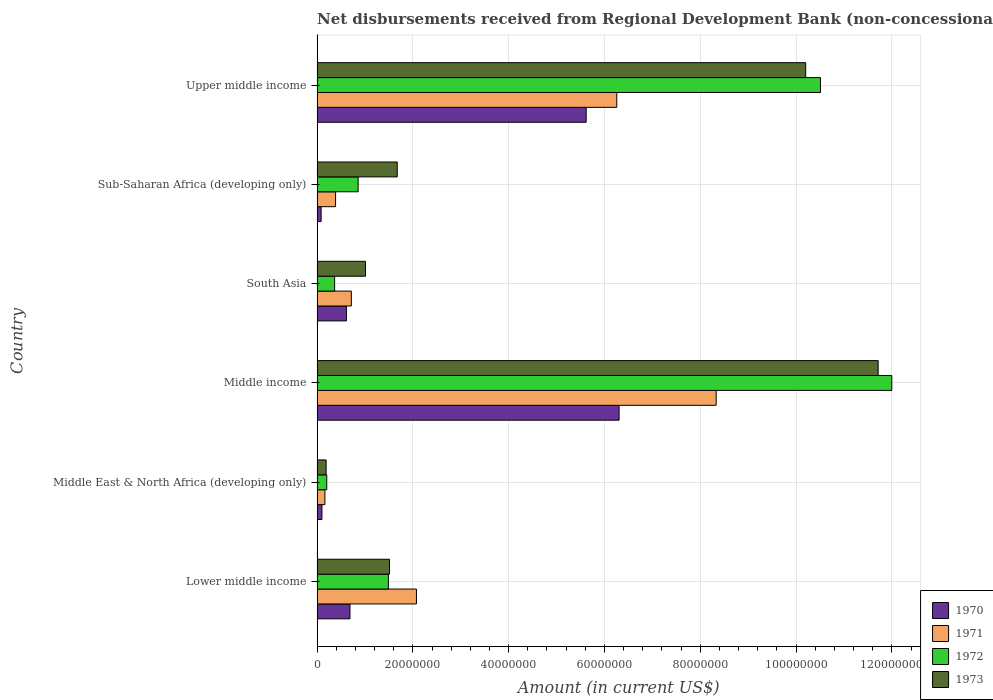How many groups of bars are there?
Your answer should be very brief. 6. Are the number of bars per tick equal to the number of legend labels?
Provide a succinct answer. Yes. What is the label of the 2nd group of bars from the top?
Make the answer very short. Sub-Saharan Africa (developing only). In how many cases, is the number of bars for a given country not equal to the number of legend labels?
Offer a very short reply. 0. What is the amount of disbursements received from Regional Development Bank in 1971 in Upper middle income?
Your answer should be compact. 6.26e+07. Across all countries, what is the maximum amount of disbursements received from Regional Development Bank in 1970?
Your answer should be compact. 6.31e+07. Across all countries, what is the minimum amount of disbursements received from Regional Development Bank in 1973?
Offer a very short reply. 1.90e+06. In which country was the amount of disbursements received from Regional Development Bank in 1971 minimum?
Your response must be concise. Middle East & North Africa (developing only). What is the total amount of disbursements received from Regional Development Bank in 1973 in the graph?
Provide a succinct answer. 2.63e+08. What is the difference between the amount of disbursements received from Regional Development Bank in 1971 in Lower middle income and that in Sub-Saharan Africa (developing only)?
Your response must be concise. 1.69e+07. What is the difference between the amount of disbursements received from Regional Development Bank in 1970 in Sub-Saharan Africa (developing only) and the amount of disbursements received from Regional Development Bank in 1971 in Middle East & North Africa (developing only)?
Ensure brevity in your answer.  -7.85e+05. What is the average amount of disbursements received from Regional Development Bank in 1970 per country?
Provide a short and direct response. 2.24e+07. What is the difference between the amount of disbursements received from Regional Development Bank in 1970 and amount of disbursements received from Regional Development Bank in 1973 in Lower middle income?
Your answer should be compact. -8.26e+06. In how many countries, is the amount of disbursements received from Regional Development Bank in 1971 greater than 116000000 US$?
Offer a terse response. 0. What is the ratio of the amount of disbursements received from Regional Development Bank in 1971 in South Asia to that in Upper middle income?
Keep it short and to the point. 0.11. What is the difference between the highest and the second highest amount of disbursements received from Regional Development Bank in 1970?
Keep it short and to the point. 6.87e+06. What is the difference between the highest and the lowest amount of disbursements received from Regional Development Bank in 1971?
Make the answer very short. 8.17e+07. Is the sum of the amount of disbursements received from Regional Development Bank in 1973 in Middle East & North Africa (developing only) and Middle income greater than the maximum amount of disbursements received from Regional Development Bank in 1971 across all countries?
Your answer should be compact. Yes. What does the 4th bar from the top in Middle income represents?
Provide a succinct answer. 1970. What does the 1st bar from the bottom in Sub-Saharan Africa (developing only) represents?
Make the answer very short. 1970. Are all the bars in the graph horizontal?
Keep it short and to the point. Yes. How many countries are there in the graph?
Offer a terse response. 6. What is the difference between two consecutive major ticks on the X-axis?
Provide a short and direct response. 2.00e+07. Are the values on the major ticks of X-axis written in scientific E-notation?
Your response must be concise. No. Does the graph contain any zero values?
Your answer should be very brief. No. Where does the legend appear in the graph?
Make the answer very short. Bottom right. How are the legend labels stacked?
Make the answer very short. Vertical. What is the title of the graph?
Your response must be concise. Net disbursements received from Regional Development Bank (non-concessional). What is the label or title of the X-axis?
Give a very brief answer. Amount (in current US$). What is the Amount (in current US$) in 1970 in Lower middle income?
Keep it short and to the point. 6.87e+06. What is the Amount (in current US$) in 1971 in Lower middle income?
Offer a very short reply. 2.08e+07. What is the Amount (in current US$) of 1972 in Lower middle income?
Ensure brevity in your answer.  1.49e+07. What is the Amount (in current US$) in 1973 in Lower middle income?
Offer a very short reply. 1.51e+07. What is the Amount (in current US$) in 1970 in Middle East & North Africa (developing only)?
Keep it short and to the point. 1.02e+06. What is the Amount (in current US$) in 1971 in Middle East & North Africa (developing only)?
Your answer should be very brief. 1.64e+06. What is the Amount (in current US$) of 1972 in Middle East & North Africa (developing only)?
Keep it short and to the point. 2.02e+06. What is the Amount (in current US$) in 1973 in Middle East & North Africa (developing only)?
Your answer should be compact. 1.90e+06. What is the Amount (in current US$) of 1970 in Middle income?
Ensure brevity in your answer.  6.31e+07. What is the Amount (in current US$) of 1971 in Middle income?
Keep it short and to the point. 8.33e+07. What is the Amount (in current US$) of 1972 in Middle income?
Offer a terse response. 1.20e+08. What is the Amount (in current US$) of 1973 in Middle income?
Give a very brief answer. 1.17e+08. What is the Amount (in current US$) of 1970 in South Asia?
Your answer should be very brief. 6.13e+06. What is the Amount (in current US$) of 1971 in South Asia?
Provide a short and direct response. 7.16e+06. What is the Amount (in current US$) in 1972 in South Asia?
Your answer should be compact. 3.67e+06. What is the Amount (in current US$) of 1973 in South Asia?
Ensure brevity in your answer.  1.01e+07. What is the Amount (in current US$) in 1970 in Sub-Saharan Africa (developing only)?
Keep it short and to the point. 8.50e+05. What is the Amount (in current US$) of 1971 in Sub-Saharan Africa (developing only)?
Your answer should be very brief. 3.87e+06. What is the Amount (in current US$) of 1972 in Sub-Saharan Africa (developing only)?
Your answer should be very brief. 8.58e+06. What is the Amount (in current US$) in 1973 in Sub-Saharan Africa (developing only)?
Give a very brief answer. 1.67e+07. What is the Amount (in current US$) in 1970 in Upper middle income?
Provide a succinct answer. 5.62e+07. What is the Amount (in current US$) of 1971 in Upper middle income?
Give a very brief answer. 6.26e+07. What is the Amount (in current US$) of 1972 in Upper middle income?
Offer a terse response. 1.05e+08. What is the Amount (in current US$) in 1973 in Upper middle income?
Your answer should be very brief. 1.02e+08. Across all countries, what is the maximum Amount (in current US$) of 1970?
Offer a terse response. 6.31e+07. Across all countries, what is the maximum Amount (in current US$) in 1971?
Provide a short and direct response. 8.33e+07. Across all countries, what is the maximum Amount (in current US$) in 1972?
Provide a short and direct response. 1.20e+08. Across all countries, what is the maximum Amount (in current US$) of 1973?
Your response must be concise. 1.17e+08. Across all countries, what is the minimum Amount (in current US$) in 1970?
Your response must be concise. 8.50e+05. Across all countries, what is the minimum Amount (in current US$) of 1971?
Provide a succinct answer. 1.64e+06. Across all countries, what is the minimum Amount (in current US$) of 1972?
Give a very brief answer. 2.02e+06. Across all countries, what is the minimum Amount (in current US$) in 1973?
Provide a succinct answer. 1.90e+06. What is the total Amount (in current US$) of 1970 in the graph?
Provide a succinct answer. 1.34e+08. What is the total Amount (in current US$) in 1971 in the graph?
Keep it short and to the point. 1.79e+08. What is the total Amount (in current US$) in 1972 in the graph?
Provide a short and direct response. 2.54e+08. What is the total Amount (in current US$) in 1973 in the graph?
Provide a succinct answer. 2.63e+08. What is the difference between the Amount (in current US$) in 1970 in Lower middle income and that in Middle East & North Africa (developing only)?
Give a very brief answer. 5.85e+06. What is the difference between the Amount (in current US$) in 1971 in Lower middle income and that in Middle East & North Africa (developing only)?
Your response must be concise. 1.91e+07. What is the difference between the Amount (in current US$) of 1972 in Lower middle income and that in Middle East & North Africa (developing only)?
Offer a very short reply. 1.29e+07. What is the difference between the Amount (in current US$) of 1973 in Lower middle income and that in Middle East & North Africa (developing only)?
Make the answer very short. 1.32e+07. What is the difference between the Amount (in current US$) in 1970 in Lower middle income and that in Middle income?
Your answer should be very brief. -5.62e+07. What is the difference between the Amount (in current US$) of 1971 in Lower middle income and that in Middle income?
Offer a very short reply. -6.26e+07. What is the difference between the Amount (in current US$) in 1972 in Lower middle income and that in Middle income?
Offer a very short reply. -1.05e+08. What is the difference between the Amount (in current US$) in 1973 in Lower middle income and that in Middle income?
Your answer should be very brief. -1.02e+08. What is the difference between the Amount (in current US$) in 1970 in Lower middle income and that in South Asia?
Your response must be concise. 7.37e+05. What is the difference between the Amount (in current US$) of 1971 in Lower middle income and that in South Asia?
Your response must be concise. 1.36e+07. What is the difference between the Amount (in current US$) of 1972 in Lower middle income and that in South Asia?
Offer a terse response. 1.12e+07. What is the difference between the Amount (in current US$) in 1973 in Lower middle income and that in South Asia?
Provide a succinct answer. 5.02e+06. What is the difference between the Amount (in current US$) of 1970 in Lower middle income and that in Sub-Saharan Africa (developing only)?
Your answer should be compact. 6.02e+06. What is the difference between the Amount (in current US$) in 1971 in Lower middle income and that in Sub-Saharan Africa (developing only)?
Your answer should be very brief. 1.69e+07. What is the difference between the Amount (in current US$) of 1972 in Lower middle income and that in Sub-Saharan Africa (developing only)?
Offer a very short reply. 6.32e+06. What is the difference between the Amount (in current US$) in 1973 in Lower middle income and that in Sub-Saharan Africa (developing only)?
Provide a succinct answer. -1.61e+06. What is the difference between the Amount (in current US$) of 1970 in Lower middle income and that in Upper middle income?
Ensure brevity in your answer.  -4.93e+07. What is the difference between the Amount (in current US$) in 1971 in Lower middle income and that in Upper middle income?
Your answer should be compact. -4.18e+07. What is the difference between the Amount (in current US$) of 1972 in Lower middle income and that in Upper middle income?
Offer a terse response. -9.02e+07. What is the difference between the Amount (in current US$) in 1973 in Lower middle income and that in Upper middle income?
Offer a terse response. -8.69e+07. What is the difference between the Amount (in current US$) in 1970 in Middle East & North Africa (developing only) and that in Middle income?
Keep it short and to the point. -6.20e+07. What is the difference between the Amount (in current US$) of 1971 in Middle East & North Africa (developing only) and that in Middle income?
Ensure brevity in your answer.  -8.17e+07. What is the difference between the Amount (in current US$) of 1972 in Middle East & North Africa (developing only) and that in Middle income?
Provide a short and direct response. -1.18e+08. What is the difference between the Amount (in current US$) of 1973 in Middle East & North Africa (developing only) and that in Middle income?
Provide a succinct answer. -1.15e+08. What is the difference between the Amount (in current US$) of 1970 in Middle East & North Africa (developing only) and that in South Asia?
Offer a very short reply. -5.11e+06. What is the difference between the Amount (in current US$) of 1971 in Middle East & North Africa (developing only) and that in South Asia?
Give a very brief answer. -5.52e+06. What is the difference between the Amount (in current US$) in 1972 in Middle East & North Africa (developing only) and that in South Asia?
Your response must be concise. -1.64e+06. What is the difference between the Amount (in current US$) of 1973 in Middle East & North Africa (developing only) and that in South Asia?
Give a very brief answer. -8.22e+06. What is the difference between the Amount (in current US$) in 1970 in Middle East & North Africa (developing only) and that in Sub-Saharan Africa (developing only)?
Provide a short and direct response. 1.71e+05. What is the difference between the Amount (in current US$) of 1971 in Middle East & North Africa (developing only) and that in Sub-Saharan Africa (developing only)?
Give a very brief answer. -2.23e+06. What is the difference between the Amount (in current US$) of 1972 in Middle East & North Africa (developing only) and that in Sub-Saharan Africa (developing only)?
Provide a succinct answer. -6.56e+06. What is the difference between the Amount (in current US$) in 1973 in Middle East & North Africa (developing only) and that in Sub-Saharan Africa (developing only)?
Offer a terse response. -1.48e+07. What is the difference between the Amount (in current US$) in 1970 in Middle East & North Africa (developing only) and that in Upper middle income?
Provide a succinct answer. -5.52e+07. What is the difference between the Amount (in current US$) of 1971 in Middle East & North Africa (developing only) and that in Upper middle income?
Provide a short and direct response. -6.09e+07. What is the difference between the Amount (in current US$) of 1972 in Middle East & North Africa (developing only) and that in Upper middle income?
Your response must be concise. -1.03e+08. What is the difference between the Amount (in current US$) in 1973 in Middle East & North Africa (developing only) and that in Upper middle income?
Ensure brevity in your answer.  -1.00e+08. What is the difference between the Amount (in current US$) in 1970 in Middle income and that in South Asia?
Your answer should be compact. 5.69e+07. What is the difference between the Amount (in current US$) of 1971 in Middle income and that in South Asia?
Provide a short and direct response. 7.62e+07. What is the difference between the Amount (in current US$) in 1972 in Middle income and that in South Asia?
Your answer should be compact. 1.16e+08. What is the difference between the Amount (in current US$) of 1973 in Middle income and that in South Asia?
Your answer should be compact. 1.07e+08. What is the difference between the Amount (in current US$) of 1970 in Middle income and that in Sub-Saharan Africa (developing only)?
Your answer should be very brief. 6.22e+07. What is the difference between the Amount (in current US$) of 1971 in Middle income and that in Sub-Saharan Africa (developing only)?
Offer a very short reply. 7.95e+07. What is the difference between the Amount (in current US$) of 1972 in Middle income and that in Sub-Saharan Africa (developing only)?
Offer a very short reply. 1.11e+08. What is the difference between the Amount (in current US$) in 1973 in Middle income and that in Sub-Saharan Africa (developing only)?
Make the answer very short. 1.00e+08. What is the difference between the Amount (in current US$) in 1970 in Middle income and that in Upper middle income?
Give a very brief answer. 6.87e+06. What is the difference between the Amount (in current US$) in 1971 in Middle income and that in Upper middle income?
Provide a short and direct response. 2.08e+07. What is the difference between the Amount (in current US$) in 1972 in Middle income and that in Upper middle income?
Offer a terse response. 1.49e+07. What is the difference between the Amount (in current US$) in 1973 in Middle income and that in Upper middle income?
Provide a short and direct response. 1.51e+07. What is the difference between the Amount (in current US$) in 1970 in South Asia and that in Sub-Saharan Africa (developing only)?
Provide a short and direct response. 5.28e+06. What is the difference between the Amount (in current US$) of 1971 in South Asia and that in Sub-Saharan Africa (developing only)?
Give a very brief answer. 3.29e+06. What is the difference between the Amount (in current US$) in 1972 in South Asia and that in Sub-Saharan Africa (developing only)?
Your answer should be compact. -4.91e+06. What is the difference between the Amount (in current US$) in 1973 in South Asia and that in Sub-Saharan Africa (developing only)?
Your answer should be very brief. -6.63e+06. What is the difference between the Amount (in current US$) of 1970 in South Asia and that in Upper middle income?
Provide a short and direct response. -5.01e+07. What is the difference between the Amount (in current US$) in 1971 in South Asia and that in Upper middle income?
Ensure brevity in your answer.  -5.54e+07. What is the difference between the Amount (in current US$) in 1972 in South Asia and that in Upper middle income?
Your answer should be very brief. -1.01e+08. What is the difference between the Amount (in current US$) in 1973 in South Asia and that in Upper middle income?
Keep it short and to the point. -9.19e+07. What is the difference between the Amount (in current US$) of 1970 in Sub-Saharan Africa (developing only) and that in Upper middle income?
Make the answer very short. -5.53e+07. What is the difference between the Amount (in current US$) in 1971 in Sub-Saharan Africa (developing only) and that in Upper middle income?
Make the answer very short. -5.87e+07. What is the difference between the Amount (in current US$) of 1972 in Sub-Saharan Africa (developing only) and that in Upper middle income?
Your answer should be compact. -9.65e+07. What is the difference between the Amount (in current US$) in 1973 in Sub-Saharan Africa (developing only) and that in Upper middle income?
Your answer should be compact. -8.53e+07. What is the difference between the Amount (in current US$) in 1970 in Lower middle income and the Amount (in current US$) in 1971 in Middle East & North Africa (developing only)?
Give a very brief answer. 5.24e+06. What is the difference between the Amount (in current US$) in 1970 in Lower middle income and the Amount (in current US$) in 1972 in Middle East & North Africa (developing only)?
Provide a succinct answer. 4.85e+06. What is the difference between the Amount (in current US$) in 1970 in Lower middle income and the Amount (in current US$) in 1973 in Middle East & North Africa (developing only)?
Ensure brevity in your answer.  4.98e+06. What is the difference between the Amount (in current US$) of 1971 in Lower middle income and the Amount (in current US$) of 1972 in Middle East & North Africa (developing only)?
Your answer should be very brief. 1.87e+07. What is the difference between the Amount (in current US$) in 1971 in Lower middle income and the Amount (in current US$) in 1973 in Middle East & North Africa (developing only)?
Your response must be concise. 1.89e+07. What is the difference between the Amount (in current US$) of 1972 in Lower middle income and the Amount (in current US$) of 1973 in Middle East & North Africa (developing only)?
Make the answer very short. 1.30e+07. What is the difference between the Amount (in current US$) of 1970 in Lower middle income and the Amount (in current US$) of 1971 in Middle income?
Your answer should be compact. -7.65e+07. What is the difference between the Amount (in current US$) in 1970 in Lower middle income and the Amount (in current US$) in 1972 in Middle income?
Ensure brevity in your answer.  -1.13e+08. What is the difference between the Amount (in current US$) in 1970 in Lower middle income and the Amount (in current US$) in 1973 in Middle income?
Your answer should be compact. -1.10e+08. What is the difference between the Amount (in current US$) in 1971 in Lower middle income and the Amount (in current US$) in 1972 in Middle income?
Provide a succinct answer. -9.92e+07. What is the difference between the Amount (in current US$) of 1971 in Lower middle income and the Amount (in current US$) of 1973 in Middle income?
Make the answer very short. -9.64e+07. What is the difference between the Amount (in current US$) in 1972 in Lower middle income and the Amount (in current US$) in 1973 in Middle income?
Your answer should be compact. -1.02e+08. What is the difference between the Amount (in current US$) of 1970 in Lower middle income and the Amount (in current US$) of 1971 in South Asia?
Ensure brevity in your answer.  -2.87e+05. What is the difference between the Amount (in current US$) in 1970 in Lower middle income and the Amount (in current US$) in 1972 in South Asia?
Offer a terse response. 3.20e+06. What is the difference between the Amount (in current US$) of 1970 in Lower middle income and the Amount (in current US$) of 1973 in South Asia?
Ensure brevity in your answer.  -3.24e+06. What is the difference between the Amount (in current US$) of 1971 in Lower middle income and the Amount (in current US$) of 1972 in South Asia?
Your answer should be compact. 1.71e+07. What is the difference between the Amount (in current US$) of 1971 in Lower middle income and the Amount (in current US$) of 1973 in South Asia?
Offer a terse response. 1.06e+07. What is the difference between the Amount (in current US$) in 1972 in Lower middle income and the Amount (in current US$) in 1973 in South Asia?
Provide a succinct answer. 4.78e+06. What is the difference between the Amount (in current US$) of 1970 in Lower middle income and the Amount (in current US$) of 1971 in Sub-Saharan Africa (developing only)?
Provide a succinct answer. 3.00e+06. What is the difference between the Amount (in current US$) in 1970 in Lower middle income and the Amount (in current US$) in 1972 in Sub-Saharan Africa (developing only)?
Offer a very short reply. -1.71e+06. What is the difference between the Amount (in current US$) of 1970 in Lower middle income and the Amount (in current US$) of 1973 in Sub-Saharan Africa (developing only)?
Your answer should be very brief. -9.87e+06. What is the difference between the Amount (in current US$) in 1971 in Lower middle income and the Amount (in current US$) in 1972 in Sub-Saharan Africa (developing only)?
Provide a succinct answer. 1.22e+07. What is the difference between the Amount (in current US$) of 1971 in Lower middle income and the Amount (in current US$) of 1973 in Sub-Saharan Africa (developing only)?
Keep it short and to the point. 4.01e+06. What is the difference between the Amount (in current US$) in 1972 in Lower middle income and the Amount (in current US$) in 1973 in Sub-Saharan Africa (developing only)?
Offer a terse response. -1.84e+06. What is the difference between the Amount (in current US$) in 1970 in Lower middle income and the Amount (in current US$) in 1971 in Upper middle income?
Offer a very short reply. -5.57e+07. What is the difference between the Amount (in current US$) in 1970 in Lower middle income and the Amount (in current US$) in 1972 in Upper middle income?
Your answer should be compact. -9.82e+07. What is the difference between the Amount (in current US$) of 1970 in Lower middle income and the Amount (in current US$) of 1973 in Upper middle income?
Your answer should be very brief. -9.51e+07. What is the difference between the Amount (in current US$) in 1971 in Lower middle income and the Amount (in current US$) in 1972 in Upper middle income?
Keep it short and to the point. -8.43e+07. What is the difference between the Amount (in current US$) of 1971 in Lower middle income and the Amount (in current US$) of 1973 in Upper middle income?
Your answer should be compact. -8.13e+07. What is the difference between the Amount (in current US$) in 1972 in Lower middle income and the Amount (in current US$) in 1973 in Upper middle income?
Make the answer very short. -8.71e+07. What is the difference between the Amount (in current US$) of 1970 in Middle East & North Africa (developing only) and the Amount (in current US$) of 1971 in Middle income?
Provide a short and direct response. -8.23e+07. What is the difference between the Amount (in current US$) in 1970 in Middle East & North Africa (developing only) and the Amount (in current US$) in 1972 in Middle income?
Provide a short and direct response. -1.19e+08. What is the difference between the Amount (in current US$) of 1970 in Middle East & North Africa (developing only) and the Amount (in current US$) of 1973 in Middle income?
Offer a very short reply. -1.16e+08. What is the difference between the Amount (in current US$) in 1971 in Middle East & North Africa (developing only) and the Amount (in current US$) in 1972 in Middle income?
Make the answer very short. -1.18e+08. What is the difference between the Amount (in current US$) of 1971 in Middle East & North Africa (developing only) and the Amount (in current US$) of 1973 in Middle income?
Provide a short and direct response. -1.16e+08. What is the difference between the Amount (in current US$) of 1972 in Middle East & North Africa (developing only) and the Amount (in current US$) of 1973 in Middle income?
Give a very brief answer. -1.15e+08. What is the difference between the Amount (in current US$) of 1970 in Middle East & North Africa (developing only) and the Amount (in current US$) of 1971 in South Asia?
Offer a terse response. -6.14e+06. What is the difference between the Amount (in current US$) of 1970 in Middle East & North Africa (developing only) and the Amount (in current US$) of 1972 in South Asia?
Your response must be concise. -2.65e+06. What is the difference between the Amount (in current US$) of 1970 in Middle East & North Africa (developing only) and the Amount (in current US$) of 1973 in South Asia?
Your response must be concise. -9.09e+06. What is the difference between the Amount (in current US$) of 1971 in Middle East & North Africa (developing only) and the Amount (in current US$) of 1972 in South Asia?
Provide a succinct answer. -2.03e+06. What is the difference between the Amount (in current US$) in 1971 in Middle East & North Africa (developing only) and the Amount (in current US$) in 1973 in South Asia?
Make the answer very short. -8.48e+06. What is the difference between the Amount (in current US$) in 1972 in Middle East & North Africa (developing only) and the Amount (in current US$) in 1973 in South Asia?
Your answer should be compact. -8.09e+06. What is the difference between the Amount (in current US$) of 1970 in Middle East & North Africa (developing only) and the Amount (in current US$) of 1971 in Sub-Saharan Africa (developing only)?
Make the answer very short. -2.85e+06. What is the difference between the Amount (in current US$) in 1970 in Middle East & North Africa (developing only) and the Amount (in current US$) in 1972 in Sub-Saharan Africa (developing only)?
Keep it short and to the point. -7.56e+06. What is the difference between the Amount (in current US$) in 1970 in Middle East & North Africa (developing only) and the Amount (in current US$) in 1973 in Sub-Saharan Africa (developing only)?
Make the answer very short. -1.57e+07. What is the difference between the Amount (in current US$) in 1971 in Middle East & North Africa (developing only) and the Amount (in current US$) in 1972 in Sub-Saharan Africa (developing only)?
Ensure brevity in your answer.  -6.95e+06. What is the difference between the Amount (in current US$) in 1971 in Middle East & North Africa (developing only) and the Amount (in current US$) in 1973 in Sub-Saharan Africa (developing only)?
Provide a short and direct response. -1.51e+07. What is the difference between the Amount (in current US$) in 1972 in Middle East & North Africa (developing only) and the Amount (in current US$) in 1973 in Sub-Saharan Africa (developing only)?
Your answer should be very brief. -1.47e+07. What is the difference between the Amount (in current US$) in 1970 in Middle East & North Africa (developing only) and the Amount (in current US$) in 1971 in Upper middle income?
Your answer should be compact. -6.16e+07. What is the difference between the Amount (in current US$) of 1970 in Middle East & North Africa (developing only) and the Amount (in current US$) of 1972 in Upper middle income?
Your response must be concise. -1.04e+08. What is the difference between the Amount (in current US$) in 1970 in Middle East & North Africa (developing only) and the Amount (in current US$) in 1973 in Upper middle income?
Offer a very short reply. -1.01e+08. What is the difference between the Amount (in current US$) of 1971 in Middle East & North Africa (developing only) and the Amount (in current US$) of 1972 in Upper middle income?
Offer a very short reply. -1.03e+08. What is the difference between the Amount (in current US$) in 1971 in Middle East & North Africa (developing only) and the Amount (in current US$) in 1973 in Upper middle income?
Your answer should be very brief. -1.00e+08. What is the difference between the Amount (in current US$) of 1972 in Middle East & North Africa (developing only) and the Amount (in current US$) of 1973 in Upper middle income?
Ensure brevity in your answer.  -1.00e+08. What is the difference between the Amount (in current US$) in 1970 in Middle income and the Amount (in current US$) in 1971 in South Asia?
Give a very brief answer. 5.59e+07. What is the difference between the Amount (in current US$) in 1970 in Middle income and the Amount (in current US$) in 1972 in South Asia?
Provide a short and direct response. 5.94e+07. What is the difference between the Amount (in current US$) of 1970 in Middle income and the Amount (in current US$) of 1973 in South Asia?
Give a very brief answer. 5.29e+07. What is the difference between the Amount (in current US$) of 1971 in Middle income and the Amount (in current US$) of 1972 in South Asia?
Your answer should be compact. 7.97e+07. What is the difference between the Amount (in current US$) of 1971 in Middle income and the Amount (in current US$) of 1973 in South Asia?
Give a very brief answer. 7.32e+07. What is the difference between the Amount (in current US$) in 1972 in Middle income and the Amount (in current US$) in 1973 in South Asia?
Offer a very short reply. 1.10e+08. What is the difference between the Amount (in current US$) in 1970 in Middle income and the Amount (in current US$) in 1971 in Sub-Saharan Africa (developing only)?
Your answer should be very brief. 5.92e+07. What is the difference between the Amount (in current US$) of 1970 in Middle income and the Amount (in current US$) of 1972 in Sub-Saharan Africa (developing only)?
Your answer should be very brief. 5.45e+07. What is the difference between the Amount (in current US$) in 1970 in Middle income and the Amount (in current US$) in 1973 in Sub-Saharan Africa (developing only)?
Ensure brevity in your answer.  4.63e+07. What is the difference between the Amount (in current US$) of 1971 in Middle income and the Amount (in current US$) of 1972 in Sub-Saharan Africa (developing only)?
Make the answer very short. 7.47e+07. What is the difference between the Amount (in current US$) of 1971 in Middle income and the Amount (in current US$) of 1973 in Sub-Saharan Africa (developing only)?
Your response must be concise. 6.66e+07. What is the difference between the Amount (in current US$) in 1972 in Middle income and the Amount (in current US$) in 1973 in Sub-Saharan Africa (developing only)?
Offer a terse response. 1.03e+08. What is the difference between the Amount (in current US$) of 1970 in Middle income and the Amount (in current US$) of 1971 in Upper middle income?
Your response must be concise. 4.82e+05. What is the difference between the Amount (in current US$) in 1970 in Middle income and the Amount (in current US$) in 1972 in Upper middle income?
Offer a very short reply. -4.20e+07. What is the difference between the Amount (in current US$) in 1970 in Middle income and the Amount (in current US$) in 1973 in Upper middle income?
Provide a short and direct response. -3.90e+07. What is the difference between the Amount (in current US$) in 1971 in Middle income and the Amount (in current US$) in 1972 in Upper middle income?
Make the answer very short. -2.18e+07. What is the difference between the Amount (in current US$) of 1971 in Middle income and the Amount (in current US$) of 1973 in Upper middle income?
Offer a terse response. -1.87e+07. What is the difference between the Amount (in current US$) of 1972 in Middle income and the Amount (in current US$) of 1973 in Upper middle income?
Provide a succinct answer. 1.80e+07. What is the difference between the Amount (in current US$) in 1970 in South Asia and the Amount (in current US$) in 1971 in Sub-Saharan Africa (developing only)?
Your response must be concise. 2.26e+06. What is the difference between the Amount (in current US$) in 1970 in South Asia and the Amount (in current US$) in 1972 in Sub-Saharan Africa (developing only)?
Keep it short and to the point. -2.45e+06. What is the difference between the Amount (in current US$) of 1970 in South Asia and the Amount (in current US$) of 1973 in Sub-Saharan Africa (developing only)?
Give a very brief answer. -1.06e+07. What is the difference between the Amount (in current US$) of 1971 in South Asia and the Amount (in current US$) of 1972 in Sub-Saharan Africa (developing only)?
Make the answer very short. -1.42e+06. What is the difference between the Amount (in current US$) in 1971 in South Asia and the Amount (in current US$) in 1973 in Sub-Saharan Africa (developing only)?
Offer a terse response. -9.58e+06. What is the difference between the Amount (in current US$) of 1972 in South Asia and the Amount (in current US$) of 1973 in Sub-Saharan Africa (developing only)?
Provide a short and direct response. -1.31e+07. What is the difference between the Amount (in current US$) in 1970 in South Asia and the Amount (in current US$) in 1971 in Upper middle income?
Your response must be concise. -5.64e+07. What is the difference between the Amount (in current US$) in 1970 in South Asia and the Amount (in current US$) in 1972 in Upper middle income?
Provide a short and direct response. -9.90e+07. What is the difference between the Amount (in current US$) of 1970 in South Asia and the Amount (in current US$) of 1973 in Upper middle income?
Ensure brevity in your answer.  -9.59e+07. What is the difference between the Amount (in current US$) of 1971 in South Asia and the Amount (in current US$) of 1972 in Upper middle income?
Your answer should be very brief. -9.79e+07. What is the difference between the Amount (in current US$) in 1971 in South Asia and the Amount (in current US$) in 1973 in Upper middle income?
Offer a terse response. -9.49e+07. What is the difference between the Amount (in current US$) of 1972 in South Asia and the Amount (in current US$) of 1973 in Upper middle income?
Your response must be concise. -9.83e+07. What is the difference between the Amount (in current US$) of 1970 in Sub-Saharan Africa (developing only) and the Amount (in current US$) of 1971 in Upper middle income?
Keep it short and to the point. -6.17e+07. What is the difference between the Amount (in current US$) of 1970 in Sub-Saharan Africa (developing only) and the Amount (in current US$) of 1972 in Upper middle income?
Your answer should be compact. -1.04e+08. What is the difference between the Amount (in current US$) in 1970 in Sub-Saharan Africa (developing only) and the Amount (in current US$) in 1973 in Upper middle income?
Make the answer very short. -1.01e+08. What is the difference between the Amount (in current US$) in 1971 in Sub-Saharan Africa (developing only) and the Amount (in current US$) in 1972 in Upper middle income?
Give a very brief answer. -1.01e+08. What is the difference between the Amount (in current US$) in 1971 in Sub-Saharan Africa (developing only) and the Amount (in current US$) in 1973 in Upper middle income?
Your answer should be very brief. -9.81e+07. What is the difference between the Amount (in current US$) of 1972 in Sub-Saharan Africa (developing only) and the Amount (in current US$) of 1973 in Upper middle income?
Ensure brevity in your answer.  -9.34e+07. What is the average Amount (in current US$) of 1970 per country?
Give a very brief answer. 2.24e+07. What is the average Amount (in current US$) in 1971 per country?
Provide a short and direct response. 2.99e+07. What is the average Amount (in current US$) of 1972 per country?
Make the answer very short. 4.24e+07. What is the average Amount (in current US$) of 1973 per country?
Offer a very short reply. 4.38e+07. What is the difference between the Amount (in current US$) of 1970 and Amount (in current US$) of 1971 in Lower middle income?
Ensure brevity in your answer.  -1.39e+07. What is the difference between the Amount (in current US$) in 1970 and Amount (in current US$) in 1972 in Lower middle income?
Your answer should be very brief. -8.03e+06. What is the difference between the Amount (in current US$) in 1970 and Amount (in current US$) in 1973 in Lower middle income?
Your response must be concise. -8.26e+06. What is the difference between the Amount (in current US$) of 1971 and Amount (in current US$) of 1972 in Lower middle income?
Give a very brief answer. 5.85e+06. What is the difference between the Amount (in current US$) of 1971 and Amount (in current US$) of 1973 in Lower middle income?
Provide a succinct answer. 5.62e+06. What is the difference between the Amount (in current US$) in 1972 and Amount (in current US$) in 1973 in Lower middle income?
Provide a short and direct response. -2.36e+05. What is the difference between the Amount (in current US$) in 1970 and Amount (in current US$) in 1971 in Middle East & North Africa (developing only)?
Your answer should be very brief. -6.14e+05. What is the difference between the Amount (in current US$) of 1970 and Amount (in current US$) of 1972 in Middle East & North Africa (developing only)?
Provide a succinct answer. -1.00e+06. What is the difference between the Amount (in current US$) of 1970 and Amount (in current US$) of 1973 in Middle East & North Africa (developing only)?
Your response must be concise. -8.75e+05. What is the difference between the Amount (in current US$) in 1971 and Amount (in current US$) in 1972 in Middle East & North Africa (developing only)?
Your answer should be compact. -3.89e+05. What is the difference between the Amount (in current US$) of 1971 and Amount (in current US$) of 1973 in Middle East & North Africa (developing only)?
Your answer should be compact. -2.61e+05. What is the difference between the Amount (in current US$) of 1972 and Amount (in current US$) of 1973 in Middle East & North Africa (developing only)?
Provide a succinct answer. 1.28e+05. What is the difference between the Amount (in current US$) of 1970 and Amount (in current US$) of 1971 in Middle income?
Provide a succinct answer. -2.03e+07. What is the difference between the Amount (in current US$) in 1970 and Amount (in current US$) in 1972 in Middle income?
Give a very brief answer. -5.69e+07. What is the difference between the Amount (in current US$) in 1970 and Amount (in current US$) in 1973 in Middle income?
Your response must be concise. -5.41e+07. What is the difference between the Amount (in current US$) in 1971 and Amount (in current US$) in 1972 in Middle income?
Provide a succinct answer. -3.67e+07. What is the difference between the Amount (in current US$) of 1971 and Amount (in current US$) of 1973 in Middle income?
Make the answer very short. -3.38e+07. What is the difference between the Amount (in current US$) of 1972 and Amount (in current US$) of 1973 in Middle income?
Your answer should be compact. 2.85e+06. What is the difference between the Amount (in current US$) in 1970 and Amount (in current US$) in 1971 in South Asia?
Provide a short and direct response. -1.02e+06. What is the difference between the Amount (in current US$) in 1970 and Amount (in current US$) in 1972 in South Asia?
Make the answer very short. 2.46e+06. What is the difference between the Amount (in current US$) in 1970 and Amount (in current US$) in 1973 in South Asia?
Provide a short and direct response. -3.98e+06. What is the difference between the Amount (in current US$) in 1971 and Amount (in current US$) in 1972 in South Asia?
Provide a succinct answer. 3.49e+06. What is the difference between the Amount (in current US$) in 1971 and Amount (in current US$) in 1973 in South Asia?
Make the answer very short. -2.95e+06. What is the difference between the Amount (in current US$) in 1972 and Amount (in current US$) in 1973 in South Asia?
Provide a succinct answer. -6.44e+06. What is the difference between the Amount (in current US$) of 1970 and Amount (in current US$) of 1971 in Sub-Saharan Africa (developing only)?
Offer a terse response. -3.02e+06. What is the difference between the Amount (in current US$) in 1970 and Amount (in current US$) in 1972 in Sub-Saharan Africa (developing only)?
Provide a short and direct response. -7.73e+06. What is the difference between the Amount (in current US$) of 1970 and Amount (in current US$) of 1973 in Sub-Saharan Africa (developing only)?
Make the answer very short. -1.59e+07. What is the difference between the Amount (in current US$) in 1971 and Amount (in current US$) in 1972 in Sub-Saharan Africa (developing only)?
Make the answer very short. -4.71e+06. What is the difference between the Amount (in current US$) of 1971 and Amount (in current US$) of 1973 in Sub-Saharan Africa (developing only)?
Make the answer very short. -1.29e+07. What is the difference between the Amount (in current US$) in 1972 and Amount (in current US$) in 1973 in Sub-Saharan Africa (developing only)?
Your answer should be compact. -8.16e+06. What is the difference between the Amount (in current US$) in 1970 and Amount (in current US$) in 1971 in Upper middle income?
Your response must be concise. -6.39e+06. What is the difference between the Amount (in current US$) of 1970 and Amount (in current US$) of 1972 in Upper middle income?
Keep it short and to the point. -4.89e+07. What is the difference between the Amount (in current US$) of 1970 and Amount (in current US$) of 1973 in Upper middle income?
Your answer should be compact. -4.58e+07. What is the difference between the Amount (in current US$) of 1971 and Amount (in current US$) of 1972 in Upper middle income?
Ensure brevity in your answer.  -4.25e+07. What is the difference between the Amount (in current US$) in 1971 and Amount (in current US$) in 1973 in Upper middle income?
Offer a terse response. -3.94e+07. What is the difference between the Amount (in current US$) in 1972 and Amount (in current US$) in 1973 in Upper middle income?
Provide a succinct answer. 3.08e+06. What is the ratio of the Amount (in current US$) of 1970 in Lower middle income to that in Middle East & North Africa (developing only)?
Keep it short and to the point. 6.73. What is the ratio of the Amount (in current US$) in 1971 in Lower middle income to that in Middle East & North Africa (developing only)?
Your answer should be compact. 12.69. What is the ratio of the Amount (in current US$) of 1972 in Lower middle income to that in Middle East & North Africa (developing only)?
Your answer should be compact. 7.36. What is the ratio of the Amount (in current US$) of 1973 in Lower middle income to that in Middle East & North Africa (developing only)?
Offer a very short reply. 7.98. What is the ratio of the Amount (in current US$) in 1970 in Lower middle income to that in Middle income?
Provide a short and direct response. 0.11. What is the ratio of the Amount (in current US$) of 1971 in Lower middle income to that in Middle income?
Your answer should be very brief. 0.25. What is the ratio of the Amount (in current US$) of 1972 in Lower middle income to that in Middle income?
Offer a terse response. 0.12. What is the ratio of the Amount (in current US$) in 1973 in Lower middle income to that in Middle income?
Your answer should be very brief. 0.13. What is the ratio of the Amount (in current US$) in 1970 in Lower middle income to that in South Asia?
Offer a very short reply. 1.12. What is the ratio of the Amount (in current US$) of 1971 in Lower middle income to that in South Asia?
Your response must be concise. 2.9. What is the ratio of the Amount (in current US$) in 1972 in Lower middle income to that in South Asia?
Provide a succinct answer. 4.06. What is the ratio of the Amount (in current US$) of 1973 in Lower middle income to that in South Asia?
Provide a short and direct response. 1.5. What is the ratio of the Amount (in current US$) of 1970 in Lower middle income to that in Sub-Saharan Africa (developing only)?
Your response must be concise. 8.08. What is the ratio of the Amount (in current US$) in 1971 in Lower middle income to that in Sub-Saharan Africa (developing only)?
Provide a short and direct response. 5.36. What is the ratio of the Amount (in current US$) of 1972 in Lower middle income to that in Sub-Saharan Africa (developing only)?
Ensure brevity in your answer.  1.74. What is the ratio of the Amount (in current US$) in 1973 in Lower middle income to that in Sub-Saharan Africa (developing only)?
Make the answer very short. 0.9. What is the ratio of the Amount (in current US$) in 1970 in Lower middle income to that in Upper middle income?
Make the answer very short. 0.12. What is the ratio of the Amount (in current US$) in 1971 in Lower middle income to that in Upper middle income?
Your response must be concise. 0.33. What is the ratio of the Amount (in current US$) of 1972 in Lower middle income to that in Upper middle income?
Give a very brief answer. 0.14. What is the ratio of the Amount (in current US$) of 1973 in Lower middle income to that in Upper middle income?
Offer a terse response. 0.15. What is the ratio of the Amount (in current US$) of 1970 in Middle East & North Africa (developing only) to that in Middle income?
Your response must be concise. 0.02. What is the ratio of the Amount (in current US$) in 1971 in Middle East & North Africa (developing only) to that in Middle income?
Your answer should be compact. 0.02. What is the ratio of the Amount (in current US$) of 1972 in Middle East & North Africa (developing only) to that in Middle income?
Provide a succinct answer. 0.02. What is the ratio of the Amount (in current US$) of 1973 in Middle East & North Africa (developing only) to that in Middle income?
Give a very brief answer. 0.02. What is the ratio of the Amount (in current US$) in 1970 in Middle East & North Africa (developing only) to that in South Asia?
Offer a very short reply. 0.17. What is the ratio of the Amount (in current US$) of 1971 in Middle East & North Africa (developing only) to that in South Asia?
Provide a succinct answer. 0.23. What is the ratio of the Amount (in current US$) of 1972 in Middle East & North Africa (developing only) to that in South Asia?
Keep it short and to the point. 0.55. What is the ratio of the Amount (in current US$) in 1973 in Middle East & North Africa (developing only) to that in South Asia?
Make the answer very short. 0.19. What is the ratio of the Amount (in current US$) of 1970 in Middle East & North Africa (developing only) to that in Sub-Saharan Africa (developing only)?
Your answer should be very brief. 1.2. What is the ratio of the Amount (in current US$) of 1971 in Middle East & North Africa (developing only) to that in Sub-Saharan Africa (developing only)?
Give a very brief answer. 0.42. What is the ratio of the Amount (in current US$) in 1972 in Middle East & North Africa (developing only) to that in Sub-Saharan Africa (developing only)?
Keep it short and to the point. 0.24. What is the ratio of the Amount (in current US$) in 1973 in Middle East & North Africa (developing only) to that in Sub-Saharan Africa (developing only)?
Provide a succinct answer. 0.11. What is the ratio of the Amount (in current US$) in 1970 in Middle East & North Africa (developing only) to that in Upper middle income?
Give a very brief answer. 0.02. What is the ratio of the Amount (in current US$) of 1971 in Middle East & North Africa (developing only) to that in Upper middle income?
Keep it short and to the point. 0.03. What is the ratio of the Amount (in current US$) of 1972 in Middle East & North Africa (developing only) to that in Upper middle income?
Your response must be concise. 0.02. What is the ratio of the Amount (in current US$) in 1973 in Middle East & North Africa (developing only) to that in Upper middle income?
Provide a short and direct response. 0.02. What is the ratio of the Amount (in current US$) of 1970 in Middle income to that in South Asia?
Keep it short and to the point. 10.28. What is the ratio of the Amount (in current US$) of 1971 in Middle income to that in South Asia?
Your answer should be very brief. 11.64. What is the ratio of the Amount (in current US$) of 1972 in Middle income to that in South Asia?
Offer a very short reply. 32.71. What is the ratio of the Amount (in current US$) in 1973 in Middle income to that in South Asia?
Your response must be concise. 11.58. What is the ratio of the Amount (in current US$) of 1970 in Middle income to that in Sub-Saharan Africa (developing only)?
Make the answer very short. 74.18. What is the ratio of the Amount (in current US$) in 1971 in Middle income to that in Sub-Saharan Africa (developing only)?
Give a very brief answer. 21.54. What is the ratio of the Amount (in current US$) in 1972 in Middle income to that in Sub-Saharan Africa (developing only)?
Ensure brevity in your answer.  13.98. What is the ratio of the Amount (in current US$) in 1973 in Middle income to that in Sub-Saharan Africa (developing only)?
Ensure brevity in your answer.  7. What is the ratio of the Amount (in current US$) in 1970 in Middle income to that in Upper middle income?
Keep it short and to the point. 1.12. What is the ratio of the Amount (in current US$) in 1971 in Middle income to that in Upper middle income?
Your response must be concise. 1.33. What is the ratio of the Amount (in current US$) in 1972 in Middle income to that in Upper middle income?
Provide a succinct answer. 1.14. What is the ratio of the Amount (in current US$) of 1973 in Middle income to that in Upper middle income?
Make the answer very short. 1.15. What is the ratio of the Amount (in current US$) of 1970 in South Asia to that in Sub-Saharan Africa (developing only)?
Keep it short and to the point. 7.22. What is the ratio of the Amount (in current US$) in 1971 in South Asia to that in Sub-Saharan Africa (developing only)?
Give a very brief answer. 1.85. What is the ratio of the Amount (in current US$) of 1972 in South Asia to that in Sub-Saharan Africa (developing only)?
Your answer should be compact. 0.43. What is the ratio of the Amount (in current US$) of 1973 in South Asia to that in Sub-Saharan Africa (developing only)?
Provide a short and direct response. 0.6. What is the ratio of the Amount (in current US$) in 1970 in South Asia to that in Upper middle income?
Your answer should be compact. 0.11. What is the ratio of the Amount (in current US$) in 1971 in South Asia to that in Upper middle income?
Offer a terse response. 0.11. What is the ratio of the Amount (in current US$) in 1972 in South Asia to that in Upper middle income?
Provide a succinct answer. 0.03. What is the ratio of the Amount (in current US$) in 1973 in South Asia to that in Upper middle income?
Provide a short and direct response. 0.1. What is the ratio of the Amount (in current US$) in 1970 in Sub-Saharan Africa (developing only) to that in Upper middle income?
Your response must be concise. 0.02. What is the ratio of the Amount (in current US$) in 1971 in Sub-Saharan Africa (developing only) to that in Upper middle income?
Keep it short and to the point. 0.06. What is the ratio of the Amount (in current US$) in 1972 in Sub-Saharan Africa (developing only) to that in Upper middle income?
Your answer should be compact. 0.08. What is the ratio of the Amount (in current US$) in 1973 in Sub-Saharan Africa (developing only) to that in Upper middle income?
Provide a succinct answer. 0.16. What is the difference between the highest and the second highest Amount (in current US$) of 1970?
Ensure brevity in your answer.  6.87e+06. What is the difference between the highest and the second highest Amount (in current US$) in 1971?
Give a very brief answer. 2.08e+07. What is the difference between the highest and the second highest Amount (in current US$) of 1972?
Offer a terse response. 1.49e+07. What is the difference between the highest and the second highest Amount (in current US$) in 1973?
Make the answer very short. 1.51e+07. What is the difference between the highest and the lowest Amount (in current US$) of 1970?
Your answer should be very brief. 6.22e+07. What is the difference between the highest and the lowest Amount (in current US$) in 1971?
Provide a succinct answer. 8.17e+07. What is the difference between the highest and the lowest Amount (in current US$) in 1972?
Give a very brief answer. 1.18e+08. What is the difference between the highest and the lowest Amount (in current US$) in 1973?
Your answer should be compact. 1.15e+08. 